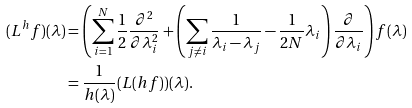Convert formula to latex. <formula><loc_0><loc_0><loc_500><loc_500>( L ^ { h } f ) ( \lambda ) & = \left ( \sum _ { i = 1 } ^ { N } \frac { 1 } { 2 } \frac { \partial ^ { 2 } } { \partial \lambda _ { i } ^ { 2 } } + \left ( \sum _ { j \neq i } \frac { 1 } { \lambda _ { i } - \lambda _ { j } } - \frac { 1 } { 2 N } \lambda _ { i } \right ) \frac { \partial } { \partial \lambda _ { i } } \right ) f ( \lambda ) \\ & = \frac { 1 } { h ( \lambda ) } ( L ( h f ) ) ( \lambda ) .</formula> 